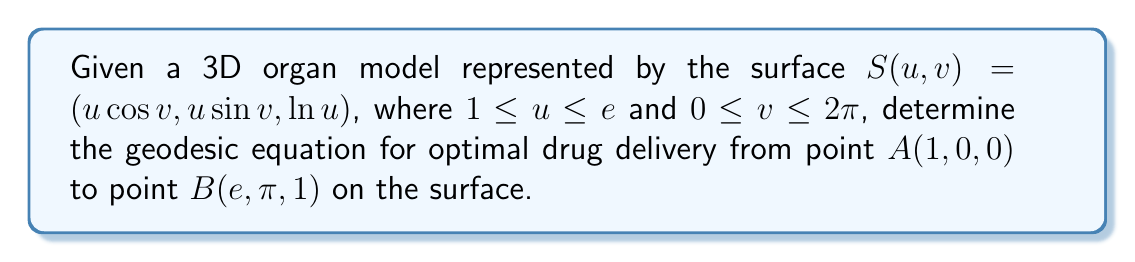Show me your answer to this math problem. To find the geodesic equation, we'll follow these steps:

1. Calculate the metric tensor $g_{ij}$:
   The first fundamental form is given by:
   $$ds^2 = E du^2 + 2F du dv + G dv^2$$
   where $E = \langle S_u, S_u \rangle$, $F = \langle S_u, S_v \rangle$, $G = \langle S_v, S_v \rangle$

   $S_u = (\cos v, \sin v, \frac{1}{u})$
   $S_v = (-u\sin v, u\cos v, 0)$

   $E = \cos^2 v + \sin^2 v + \frac{1}{u^2} = 1 + \frac{1}{u^2}$
   $F = -u\sin v \cos v + u\cos v \sin v = 0$
   $G = u^2\sin^2 v + u^2\cos^2 v = u^2$

   The metric tensor is:
   $$g_{ij} = \begin{pmatrix} 1 + \frac{1}{u^2} & 0 \\ 0 & u^2 \end{pmatrix}$$

2. Calculate the Christoffel symbols:
   $$\Gamma_{ij}^k = \frac{1}{2}g^{kl}(\partial_i g_{jl} + \partial_j g_{il} - \partial_l g_{ij})$$

   Non-zero Christoffel symbols:
   $\Gamma_{11}^1 = \frac{1}{u(u^2+1)}$
   $\Gamma_{12}^2 = \Gamma_{21}^2 = \frac{1}{u}$
   $\Gamma_{22}^1 = -\frac{u^3}{u^2+1}$

3. Write the geodesic equations:
   $$\frac{d^2u}{dt^2} + \Gamma_{11}^1 (\frac{du}{dt})^2 + 2\Gamma_{12}^2 \frac{du}{dt}\frac{dv}{dt} + \Gamma_{22}^1 (\frac{dv}{dt})^2 = 0$$
   $$\frac{d^2v}{dt^2} + 2\Gamma_{12}^2 \frac{du}{dt}\frac{dv}{dt} = 0$$

4. Substitute the Christoffel symbols:
   $$\frac{d^2u}{dt^2} + \frac{1}{u(u^2+1)} (\frac{du}{dt})^2 + \frac{2}{u} \frac{du}{dt}\frac{dv}{dt} - \frac{u^3}{u^2+1} (\frac{dv}{dt})^2 = 0$$
   $$\frac{d^2v}{dt^2} + \frac{2}{u} \frac{du}{dt}\frac{dv}{dt} = 0$$

These coupled differential equations describe the geodesic path for optimal drug delivery on the given 3D organ model.
Answer: $$\begin{cases}
\frac{d^2u}{dt^2} + \frac{1}{u(u^2+1)} (\frac{du}{dt})^2 + \frac{2}{u} \frac{du}{dt}\frac{dv}{dt} - \frac{u^3}{u^2+1} (\frac{dv}{dt})^2 = 0 \\
\frac{d^2v}{dt^2} + \frac{2}{u} \frac{du}{dt}\frac{dv}{dt} = 0
\end{cases}$$ 